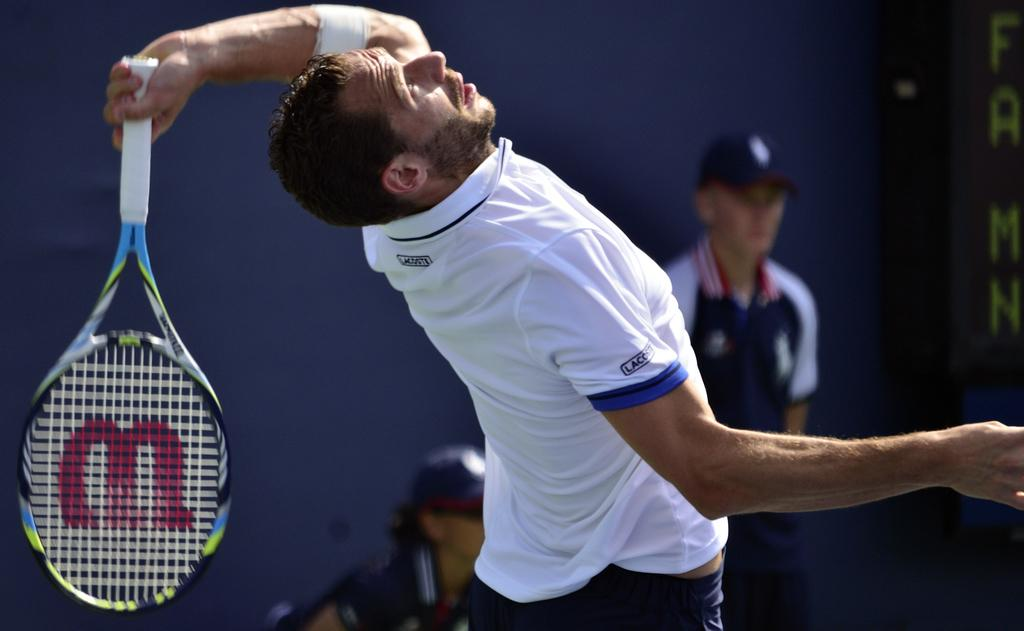What is the person in the image holding? The person in the image is holding a tennis racket. Can you describe the people behind the person with the tennis racket? There are two people behind the person with the tennis racket. What is present on the right side of the image? There is some text on the right side of the image. What type of plate is being used by the person in the image? There is no plate present in the image; the person is holding a tennis racket. What room is the image taken in? The image does not provide information about the room or location where it was taken. 